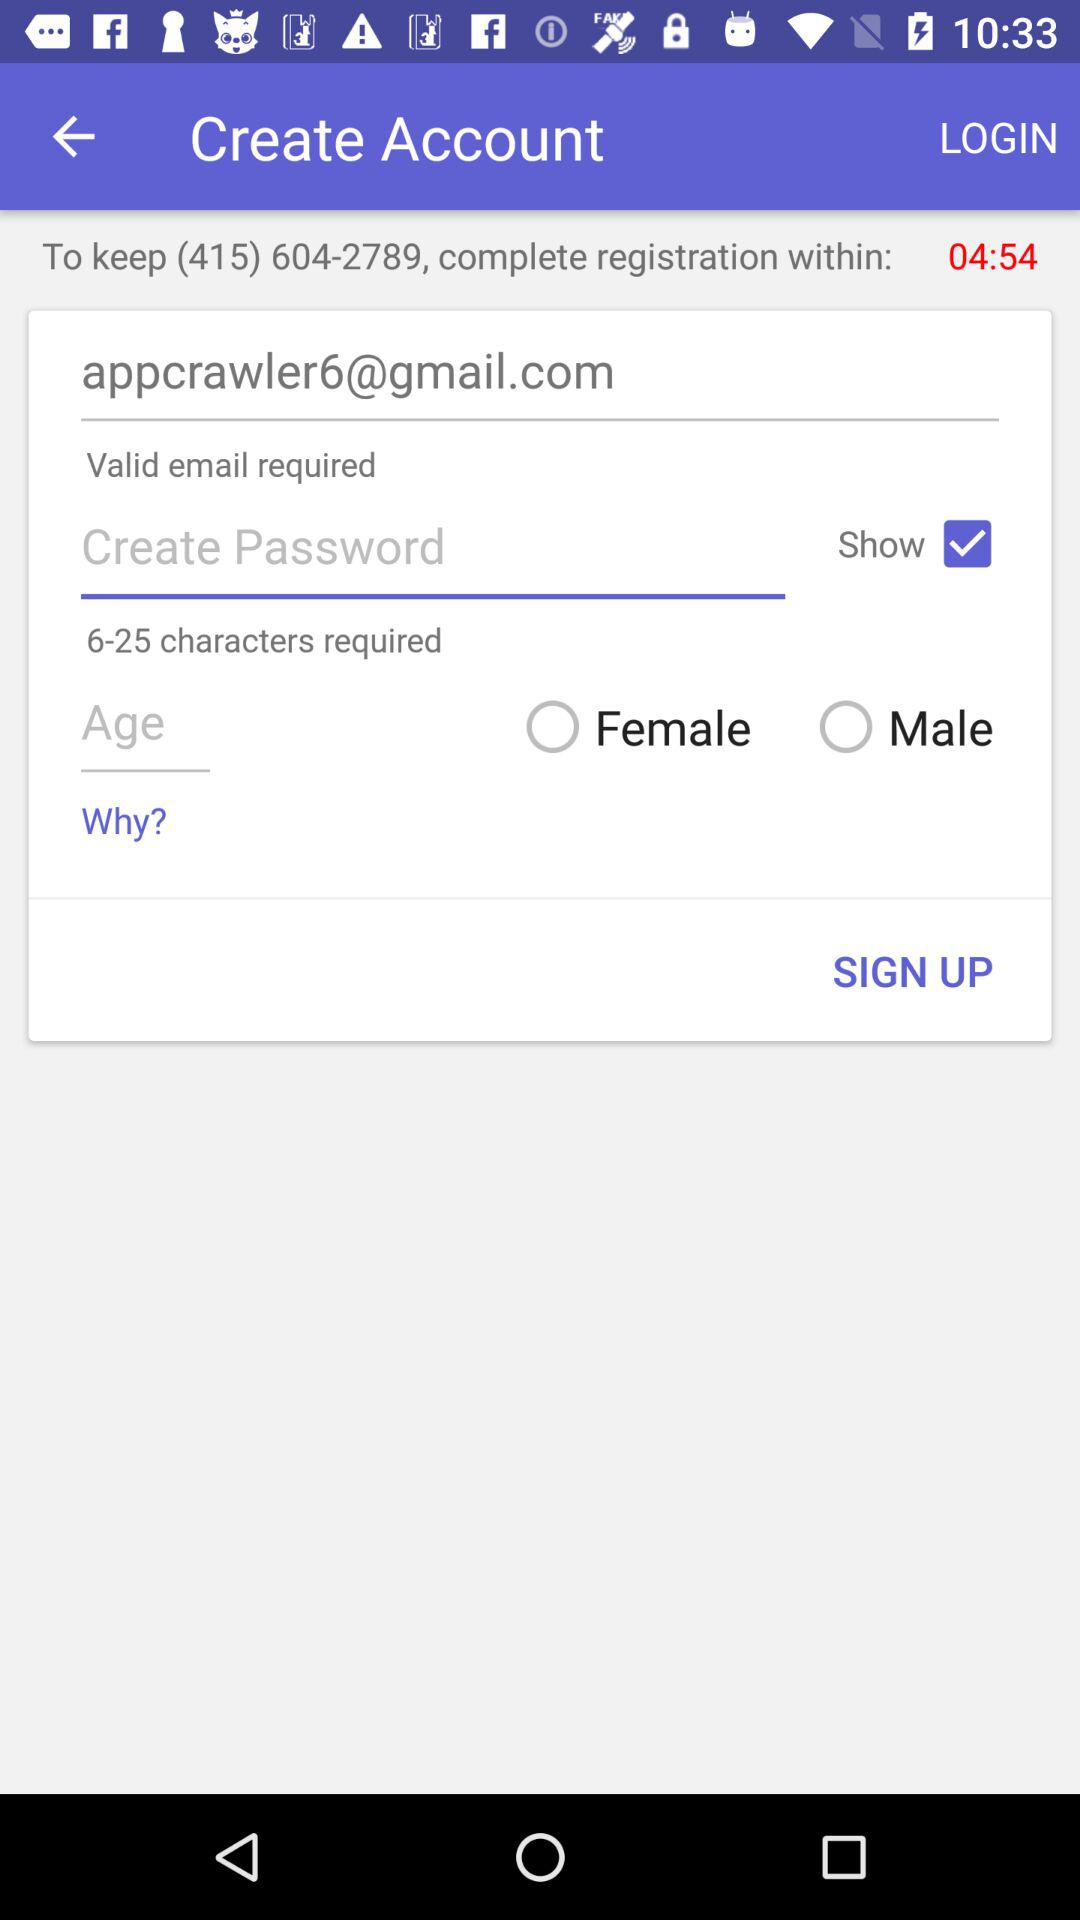What are the available gender options? The available gender options are "Female" and "Male". 